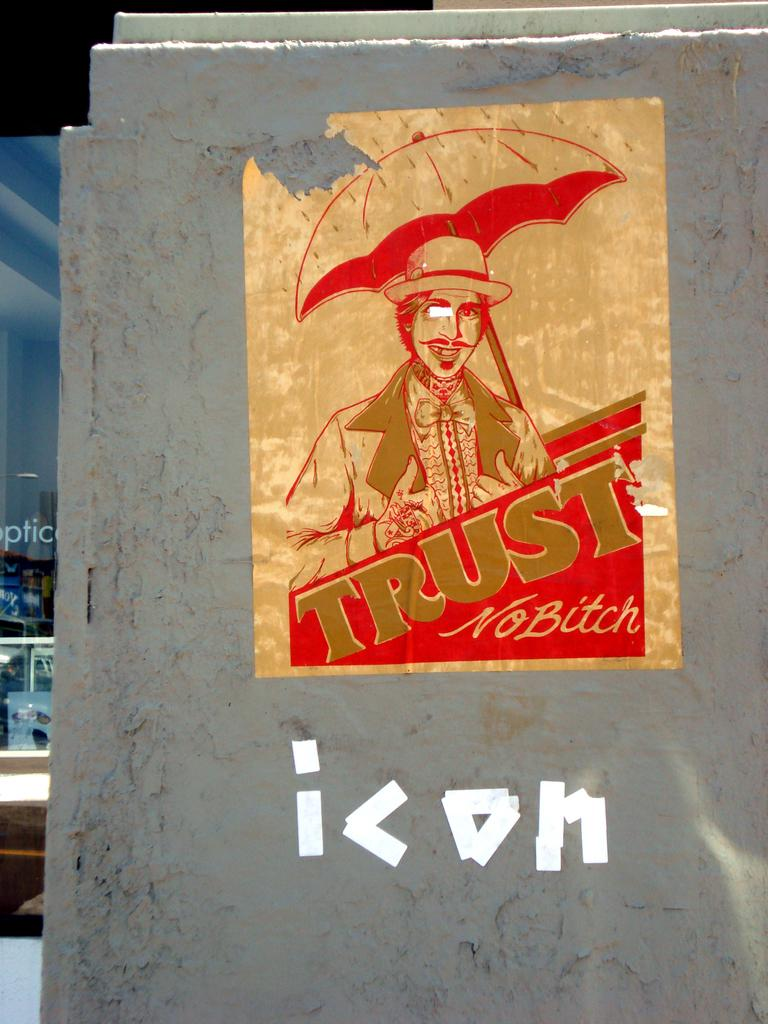What type of wall is visible in the image? There is a marble wall in the image. What is on the wall in the image? There is a poster on the wall. What is depicted on the poster? The poster features a man and an umbrella. What phrase is written on the poster? The text "trust no bitch" is written on the poster. Where are the scissors located in the image? There are no scissors present in the image. What type of vegetable is featured on the poster? The poster does not feature any vegetables; it depicts a man and an umbrella. 